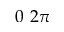<formula> <loc_0><loc_0><loc_500><loc_500>0 2 \pi</formula> 